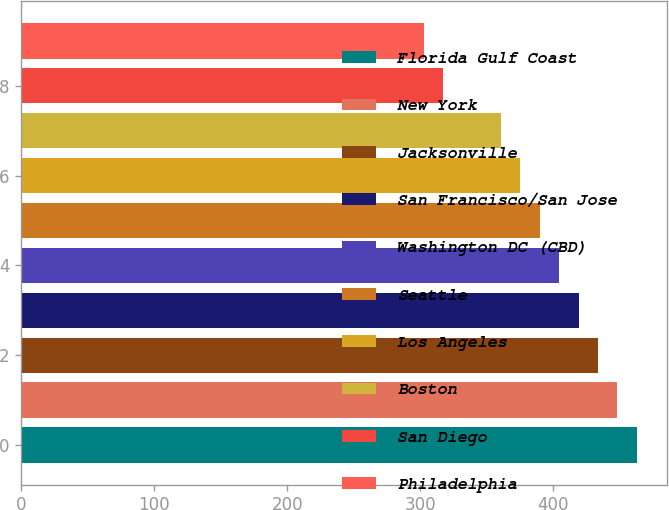<chart> <loc_0><loc_0><loc_500><loc_500><bar_chart><fcel>Florida Gulf Coast<fcel>New York<fcel>Jacksonville<fcel>San Francisco/San Jose<fcel>Washington DC (CBD)<fcel>Seattle<fcel>Los Angeles<fcel>Boston<fcel>San Diego<fcel>Philadelphia<nl><fcel>462.97<fcel>448.39<fcel>433.81<fcel>419.23<fcel>404.65<fcel>390.07<fcel>375.49<fcel>360.91<fcel>317.17<fcel>302.59<nl></chart> 